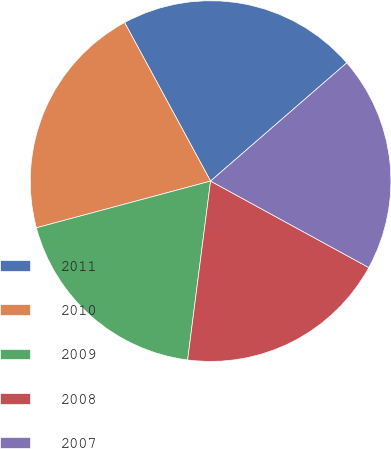<chart> <loc_0><loc_0><loc_500><loc_500><pie_chart><fcel>2011<fcel>2010<fcel>2009<fcel>2008<fcel>2007<nl><fcel>21.53%<fcel>21.26%<fcel>18.8%<fcel>19.07%<fcel>19.34%<nl></chart> 